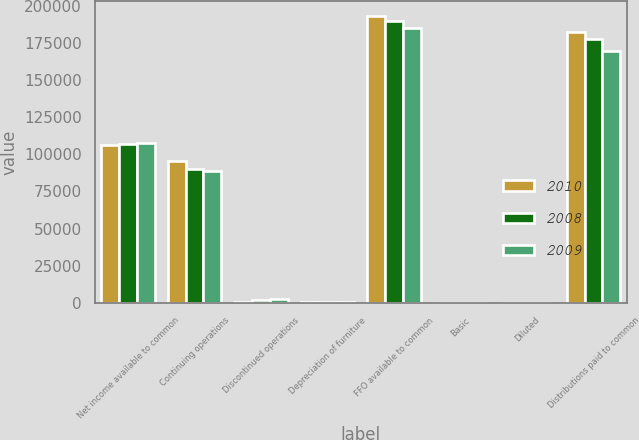Convert chart. <chart><loc_0><loc_0><loc_500><loc_500><stacked_bar_chart><ecel><fcel>Net income available to common<fcel>Continuing operations<fcel>Discontinued operations<fcel>Depreciation of furniture<fcel>FFO available to common<fcel>Basic<fcel>Diluted<fcel>Distributions paid to common<nl><fcel>2010<fcel>106531<fcel>95513<fcel>636<fcel>291<fcel>193713<fcel>1.83<fcel>1.83<fcel>182500<nl><fcel>2008<fcel>106874<fcel>90519<fcel>1428<fcel>318<fcel>190444<fcel>1.84<fcel>1.84<fcel>178008<nl><fcel>2009<fcel>107588<fcel>89104<fcel>2701<fcel>319<fcel>185524<fcel>1.83<fcel>1.83<fcel>169655<nl></chart> 